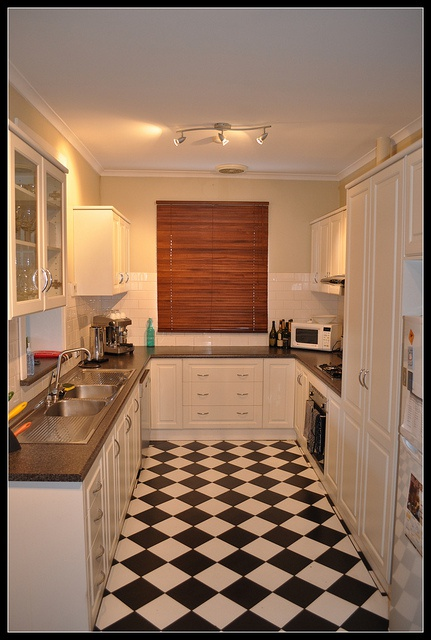Describe the objects in this image and their specific colors. I can see refrigerator in black, gray, and darkgray tones, sink in black, gray, brown, and maroon tones, microwave in black, tan, and gray tones, oven in black, brown, maroon, and gray tones, and cup in black, gray, olive, tan, and darkgray tones in this image. 